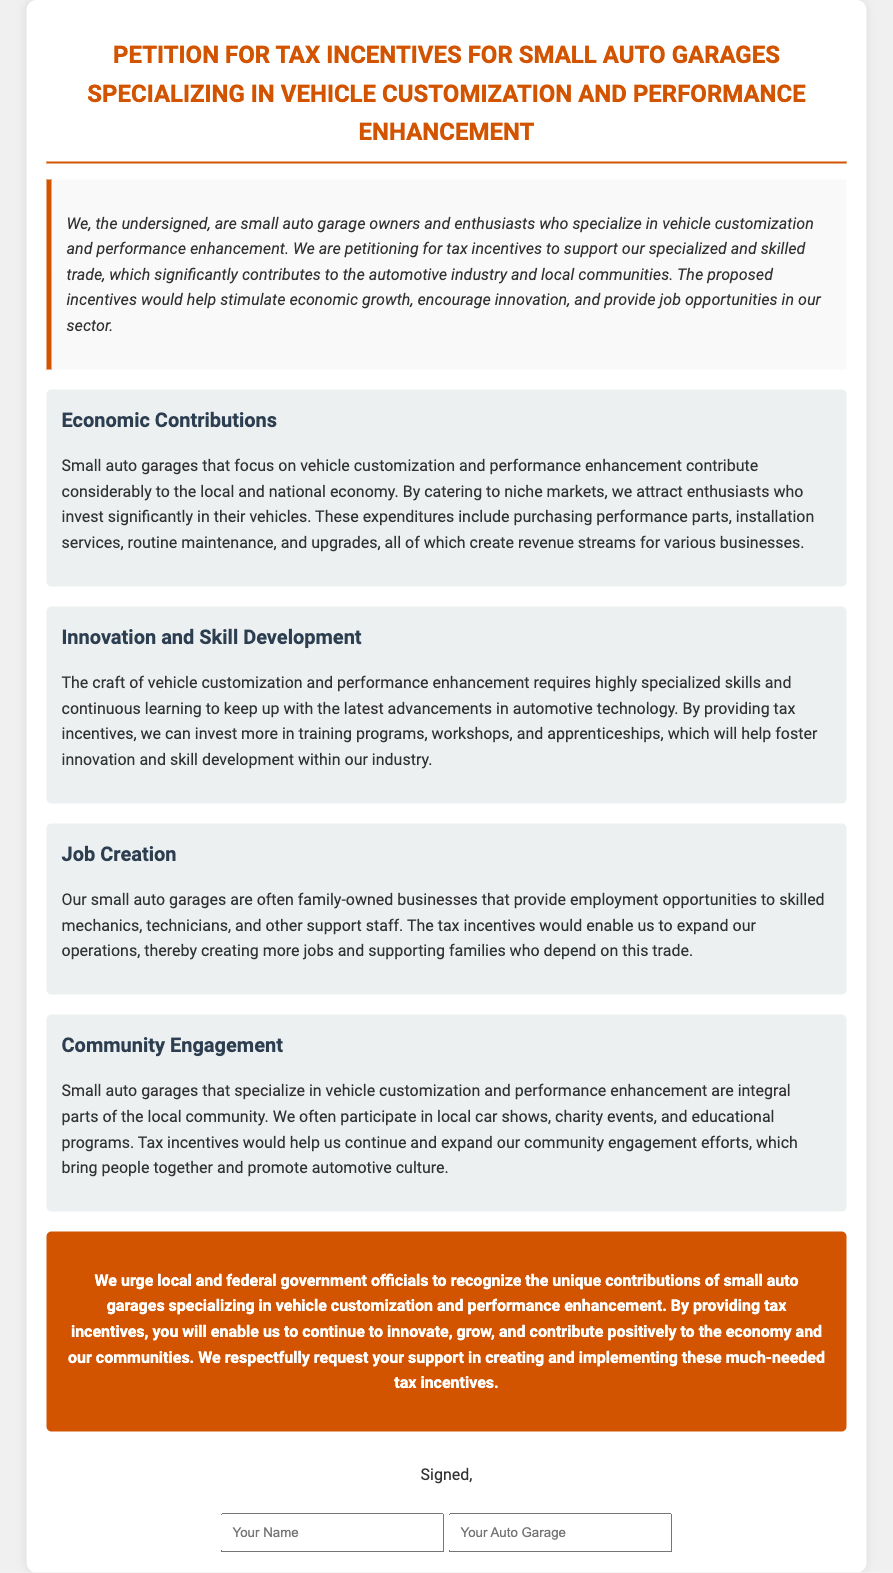What is the main purpose of the petition? The main purpose of the petition is to request tax incentives for small auto garages specializing in vehicle customization and performance enhancement.
Answer: tax incentives Who are the petitioners? The petitioners are small auto garage owners and enthusiasts who specialize in vehicle customization and performance enhancement.
Answer: small auto garage owners and enthusiasts What is one economic contribution mentioned in the document? The document states that small auto garages contribute to the local and national economy by catering to niche markets.
Answer: catering to niche markets What type of skills are emphasized in the Innovation and Skill Development section? The document emphasizes specialized skills and continuous learning to keep up with the latest advancements in automotive technology.
Answer: specialized skills How do the garages contribute to job creation? The garages provide employment opportunities to skilled mechanics, technicians, and other support staff.
Answer: employment opportunities What is a community activity mentioned in the document? The document mentions participation in local car shows and charity events as community activities.
Answer: local car shows What is the color of the section headers in the document? The section headers are colored dark blue according to the document styling.
Answer: dark blue What is being urged from local and federal government officials? They are urged to recognize the unique contributions of small auto garages and provide tax incentives.
Answer: provide tax incentives What is featured at the bottom of the petition for signatures? The bottom of the petition features fields for name and auto garage for signatures.
Answer: fields for name and auto garage 